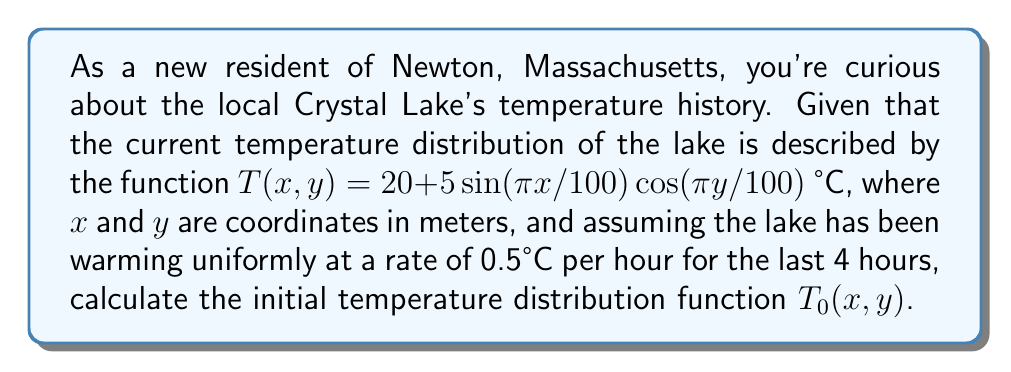Could you help me with this problem? To solve this inverse problem, we need to work backwards from the given current temperature distribution to find the initial distribution. Let's approach this step-by-step:

1) The current temperature distribution is given by:
   $T(x,y) = 20 + 5\sin(\pi x/100)\cos(\pi y/100)$ °C

2) We're told that the lake has been warming uniformly at 0.5°C per hour for 4 hours. This means the total temperature increase is:
   $\Delta T = 0.5 \text{ °C/hour} \times 4 \text{ hours} = 2$ °C

3) To find the initial temperature distribution, we need to subtract this uniform increase from the current distribution:
   $T_0(x,y) = T(x,y) - \Delta T$

4) Substituting the values:
   $T_0(x,y) = [20 + 5\sin(\pi x/100)\cos(\pi y/100)] - 2$

5) Simplifying:
   $T_0(x,y) = 18 + 5\sin(\pi x/100)\cos(\pi y/100)$ °C

This function represents the initial temperature distribution of Crystal Lake 4 hours ago.
Answer: $T_0(x,y) = 18 + 5\sin(\pi x/100)\cos(\pi y/100)$ °C 